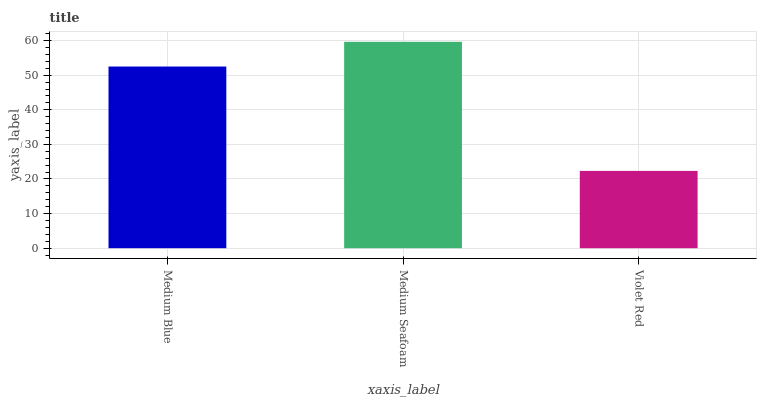Is Medium Seafoam the minimum?
Answer yes or no. No. Is Violet Red the maximum?
Answer yes or no. No. Is Medium Seafoam greater than Violet Red?
Answer yes or no. Yes. Is Violet Red less than Medium Seafoam?
Answer yes or no. Yes. Is Violet Red greater than Medium Seafoam?
Answer yes or no. No. Is Medium Seafoam less than Violet Red?
Answer yes or no. No. Is Medium Blue the high median?
Answer yes or no. Yes. Is Medium Blue the low median?
Answer yes or no. Yes. Is Violet Red the high median?
Answer yes or no. No. Is Medium Seafoam the low median?
Answer yes or no. No. 